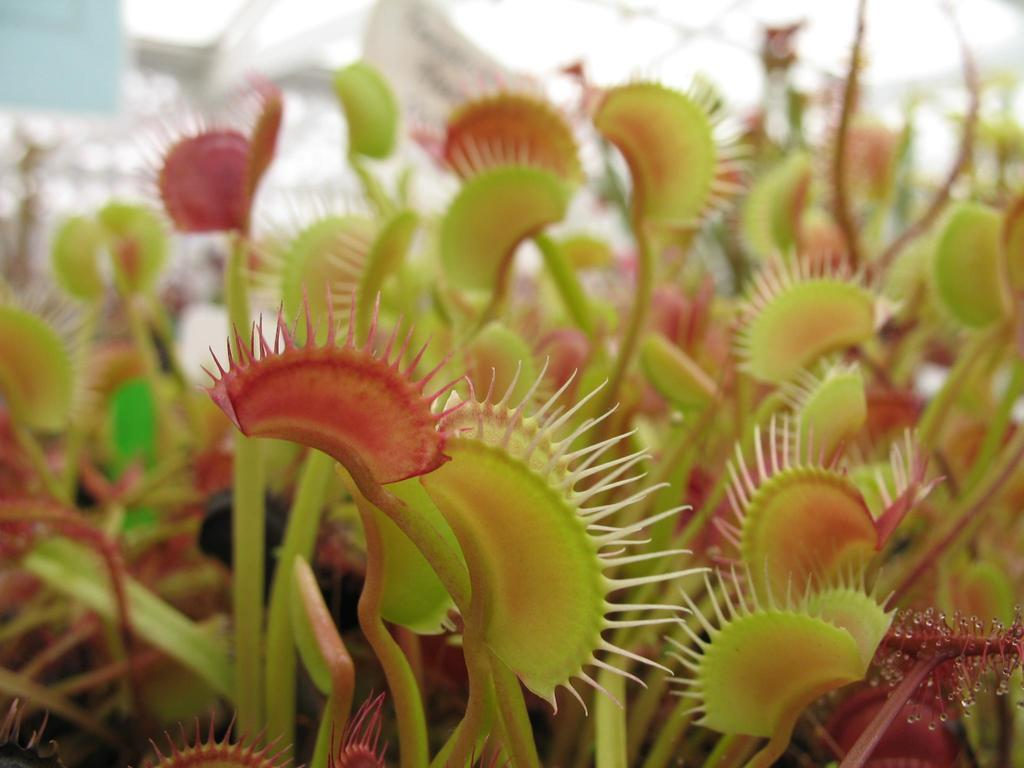What type of plants are featured in the image? There are carnivorous plants in the image. Can you describe the background of the image? The background of the image is blurred. What type of clouds can be seen in the image? There are no clouds visible in the image, as the background is blurred and does not show any clouds. 